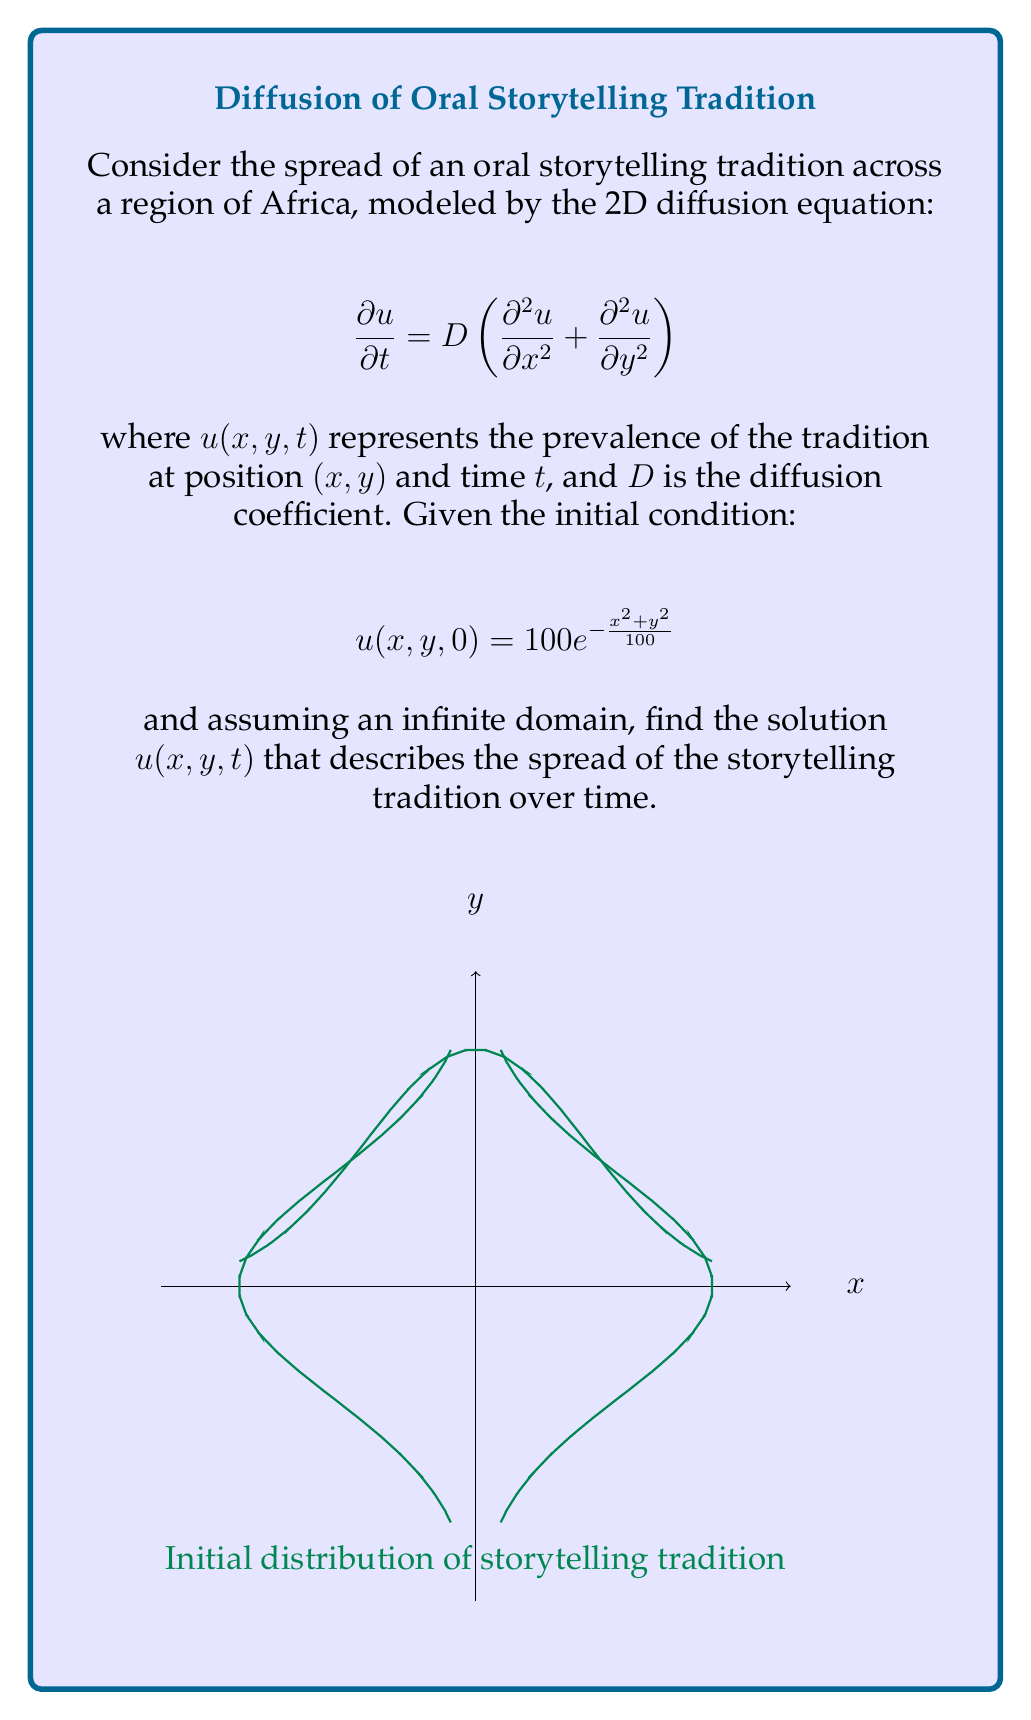Help me with this question. To solve this diffusion equation, we'll follow these steps:

1) The general solution for a 2D diffusion equation with an initial condition $u(x,y,0) = f(x,y)$ is given by:

   $$u(x,y,t) = \frac{1}{4\pi Dt}\int_{-\infty}^{\infty}\int_{-\infty}^{\infty} f(\xi,\eta)e^{-\frac{(x-\xi)^2+(y-\eta)^2}{4Dt}}d\xi d\eta$$

2) In our case, $f(x,y) = 100e^{-\frac{x^2+y^2}{100}}$

3) Substituting this into the general solution:

   $$u(x,y,t) = \frac{100}{4\pi Dt}\int_{-\infty}^{\infty}\int_{-\infty}^{\infty} e^{-\frac{\xi^2+\eta^2}{100}}e^{-\frac{(x-\xi)^2+(y-\eta)^2}{4Dt}}d\xi d\eta$$

4) This integral can be solved using the convolution of Gaussians property. The result is:

   $$u(x,y,t) = \frac{100}{1+\frac{4Dt}{100}}e^{-\frac{x^2+y^2}{100+4Dt}}$$

5) This solution represents how the initial Gaussian distribution of the storytelling tradition spreads out over time, becoming wider and less intense as $t$ increases.
Answer: $$u(x,y,t) = \frac{100}{1+\frac{4Dt}{100}}e^{-\frac{x^2+y^2}{100+4Dt}}$$ 